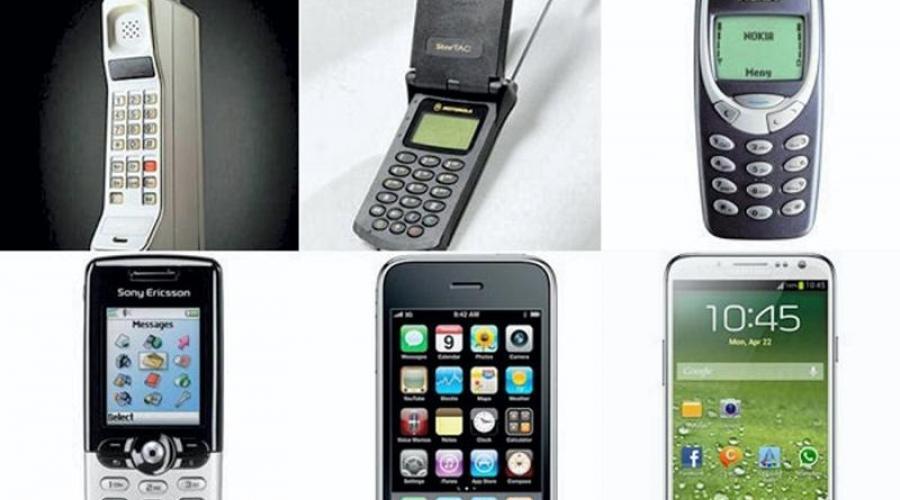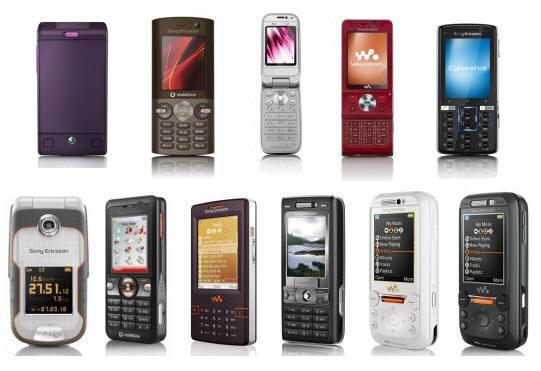The first image is the image on the left, the second image is the image on the right. Examine the images to the left and right. Is the description "One of the pictures shows at least six phones side by side." accurate? Answer yes or no. Yes. The first image is the image on the left, the second image is the image on the right. Analyze the images presented: Is the assertion "One image shows exactly three phones, and the other image shows a single row containing at least four phones." valid? Answer yes or no. No. 